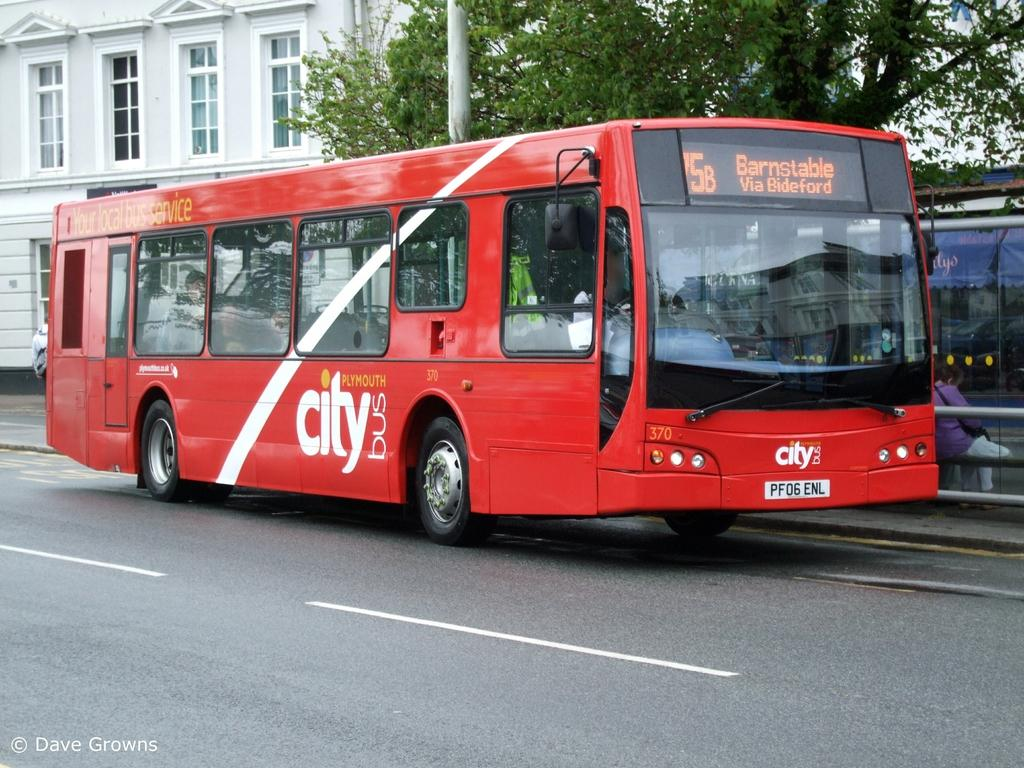<image>
Write a terse but informative summary of the picture. A red Plymouth city bus headed to Barnstable. 